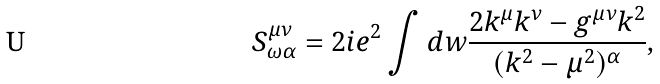<formula> <loc_0><loc_0><loc_500><loc_500>S _ { \omega \alpha } ^ { \mu \nu } = 2 i e ^ { 2 } \int d w \frac { 2 k ^ { \mu } k ^ { \nu } - g ^ { \mu \nu } k ^ { 2 } } { ( k ^ { 2 } - \mu ^ { 2 } ) ^ { \alpha } } ,</formula> 